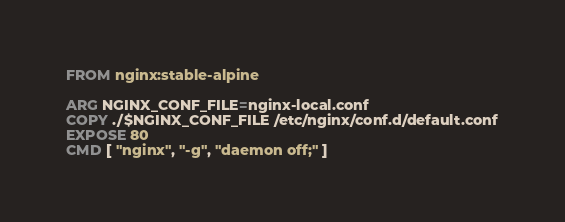<code> <loc_0><loc_0><loc_500><loc_500><_Dockerfile_>
FROM nginx:stable-alpine

ARG NGINX_CONF_FILE=nginx-local.conf
COPY ./$NGINX_CONF_FILE /etc/nginx/conf.d/default.conf
EXPOSE 80
CMD [ "nginx", "-g", "daemon off;" ]
</code> 